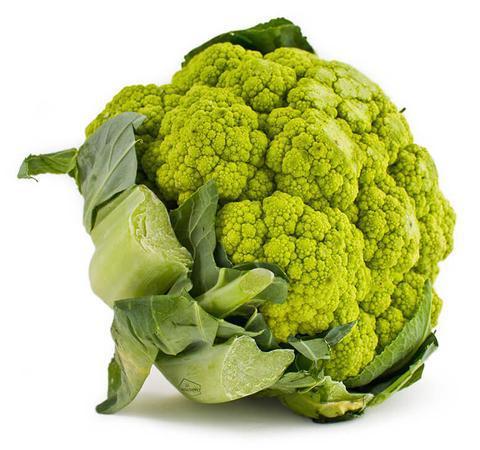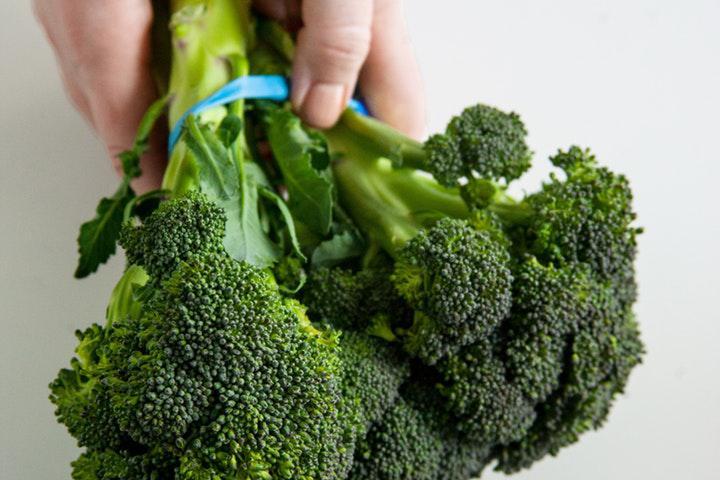The first image is the image on the left, the second image is the image on the right. Considering the images on both sides, is "In at least one image there is a single head of green cauliflower." valid? Answer yes or no. Yes. The first image is the image on the left, the second image is the image on the right. Given the left and right images, does the statement "One image shows one roundish head of a yellow-green cauliflower type vegetable, and the other image features darker green broccoli florets." hold true? Answer yes or no. Yes. 